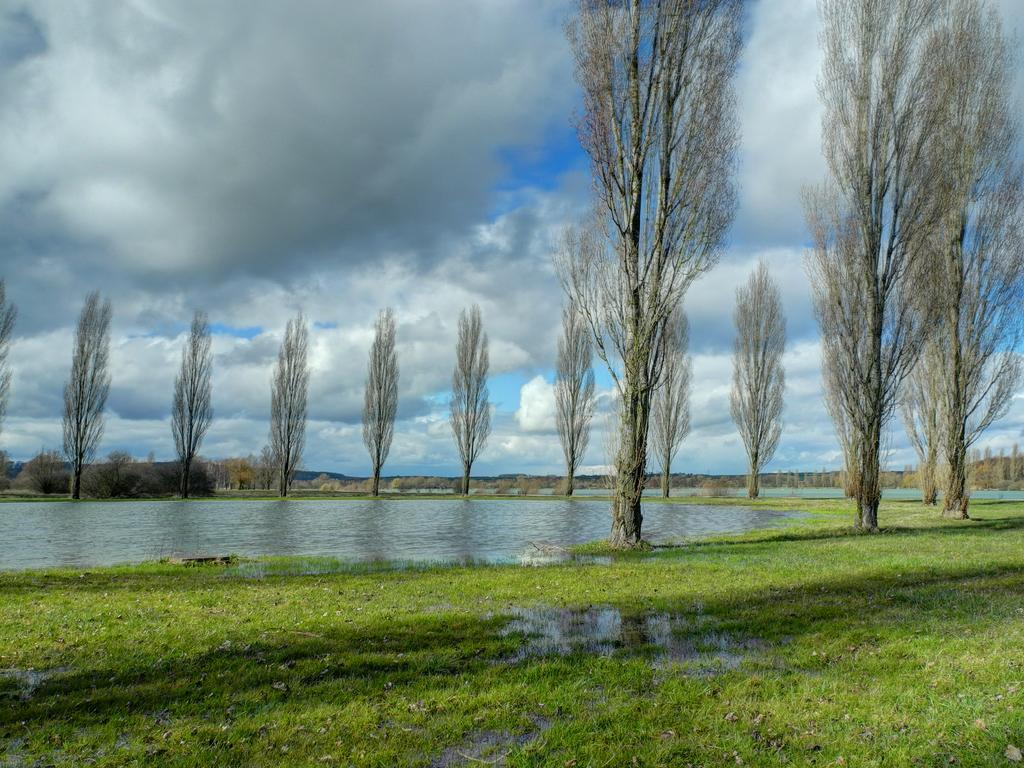What type of landscape is depicted in the image? There is a grassland in the image. What can be seen in the distance behind the grassland? There is a water surface and a tree in the background of the image. What part of the natural environment is visible in the image? The sky is visible in the background of the image. What type of paper can be seen blowing in the wind in the image? There is no paper present in the image; it features a grassland, water surface, tree, and sky. 